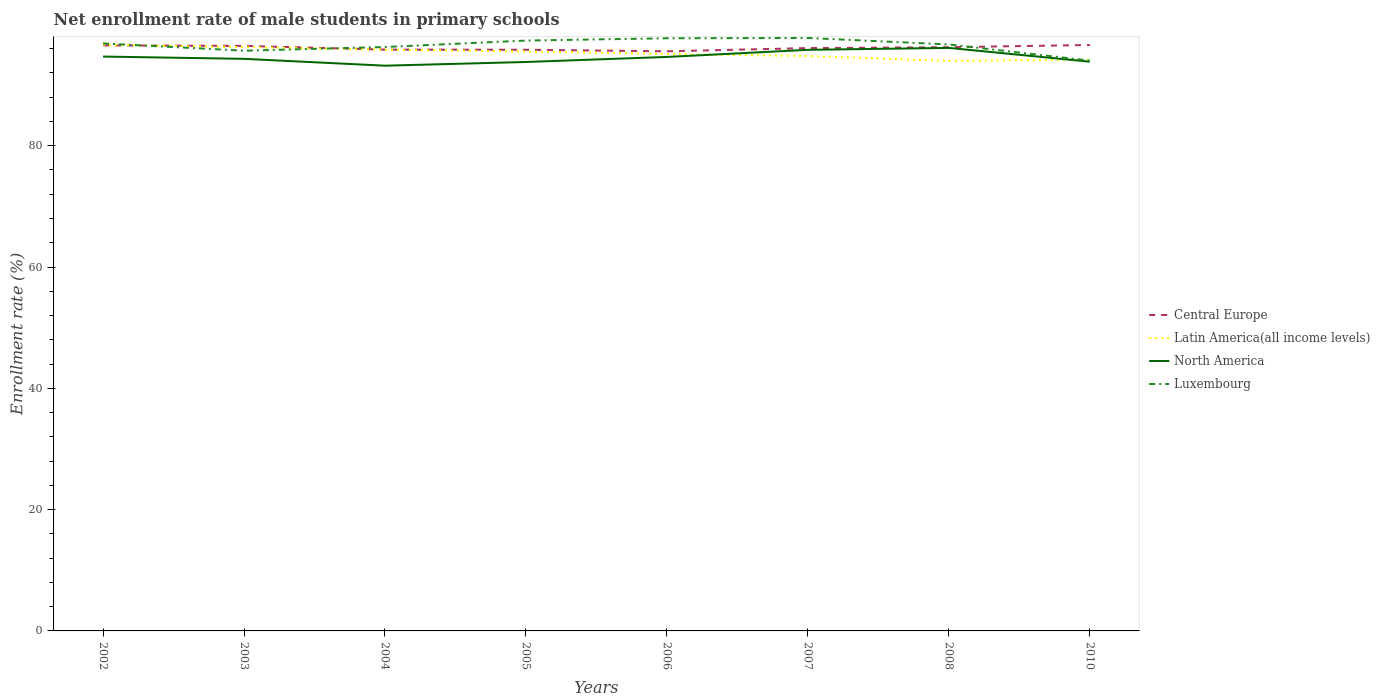Does the line corresponding to North America intersect with the line corresponding to Central Europe?
Your answer should be very brief. No. Across all years, what is the maximum net enrollment rate of male students in primary schools in Latin America(all income levels)?
Make the answer very short. 93.98. What is the total net enrollment rate of male students in primary schools in Central Europe in the graph?
Offer a terse response. 0.36. What is the difference between the highest and the second highest net enrollment rate of male students in primary schools in Luxembourg?
Ensure brevity in your answer.  3.74. Is the net enrollment rate of male students in primary schools in Latin America(all income levels) strictly greater than the net enrollment rate of male students in primary schools in Luxembourg over the years?
Keep it short and to the point. No. How many years are there in the graph?
Offer a very short reply. 8. Are the values on the major ticks of Y-axis written in scientific E-notation?
Offer a very short reply. No. Does the graph contain any zero values?
Your answer should be compact. No. Where does the legend appear in the graph?
Offer a terse response. Center right. How are the legend labels stacked?
Provide a short and direct response. Vertical. What is the title of the graph?
Make the answer very short. Net enrollment rate of male students in primary schools. What is the label or title of the Y-axis?
Offer a terse response. Enrollment rate (%). What is the Enrollment rate (%) of Central Europe in 2002?
Offer a very short reply. 96.54. What is the Enrollment rate (%) of Latin America(all income levels) in 2002?
Offer a terse response. 96.65. What is the Enrollment rate (%) in North America in 2002?
Offer a terse response. 94.7. What is the Enrollment rate (%) of Luxembourg in 2002?
Offer a terse response. 96.87. What is the Enrollment rate (%) in Central Europe in 2003?
Your answer should be very brief. 96.46. What is the Enrollment rate (%) in Latin America(all income levels) in 2003?
Your answer should be compact. 96.26. What is the Enrollment rate (%) of North America in 2003?
Keep it short and to the point. 94.32. What is the Enrollment rate (%) of Luxembourg in 2003?
Keep it short and to the point. 95.67. What is the Enrollment rate (%) of Central Europe in 2004?
Give a very brief answer. 95.85. What is the Enrollment rate (%) in Latin America(all income levels) in 2004?
Provide a succinct answer. 95.84. What is the Enrollment rate (%) in North America in 2004?
Your response must be concise. 93.19. What is the Enrollment rate (%) of Luxembourg in 2004?
Ensure brevity in your answer.  96.28. What is the Enrollment rate (%) in Central Europe in 2005?
Offer a terse response. 95.82. What is the Enrollment rate (%) of Latin America(all income levels) in 2005?
Offer a terse response. 95.53. What is the Enrollment rate (%) in North America in 2005?
Keep it short and to the point. 93.8. What is the Enrollment rate (%) in Luxembourg in 2005?
Make the answer very short. 97.34. What is the Enrollment rate (%) of Central Europe in 2006?
Your answer should be compact. 95.56. What is the Enrollment rate (%) in Latin America(all income levels) in 2006?
Provide a succinct answer. 95.13. What is the Enrollment rate (%) of North America in 2006?
Provide a succinct answer. 94.64. What is the Enrollment rate (%) in Luxembourg in 2006?
Your response must be concise. 97.72. What is the Enrollment rate (%) of Central Europe in 2007?
Your response must be concise. 96.1. What is the Enrollment rate (%) in Latin America(all income levels) in 2007?
Provide a succinct answer. 94.79. What is the Enrollment rate (%) in North America in 2007?
Provide a succinct answer. 95.81. What is the Enrollment rate (%) in Luxembourg in 2007?
Make the answer very short. 97.77. What is the Enrollment rate (%) of Central Europe in 2008?
Ensure brevity in your answer.  96.24. What is the Enrollment rate (%) of Latin America(all income levels) in 2008?
Offer a very short reply. 93.98. What is the Enrollment rate (%) in North America in 2008?
Offer a very short reply. 96.13. What is the Enrollment rate (%) in Luxembourg in 2008?
Provide a short and direct response. 96.69. What is the Enrollment rate (%) of Central Europe in 2010?
Provide a succinct answer. 96.6. What is the Enrollment rate (%) in Latin America(all income levels) in 2010?
Give a very brief answer. 94.16. What is the Enrollment rate (%) of North America in 2010?
Your answer should be compact. 93.85. What is the Enrollment rate (%) in Luxembourg in 2010?
Your answer should be very brief. 94.03. Across all years, what is the maximum Enrollment rate (%) in Central Europe?
Give a very brief answer. 96.6. Across all years, what is the maximum Enrollment rate (%) in Latin America(all income levels)?
Give a very brief answer. 96.65. Across all years, what is the maximum Enrollment rate (%) in North America?
Ensure brevity in your answer.  96.13. Across all years, what is the maximum Enrollment rate (%) of Luxembourg?
Keep it short and to the point. 97.77. Across all years, what is the minimum Enrollment rate (%) in Central Europe?
Your response must be concise. 95.56. Across all years, what is the minimum Enrollment rate (%) in Latin America(all income levels)?
Provide a succinct answer. 93.98. Across all years, what is the minimum Enrollment rate (%) of North America?
Your answer should be compact. 93.19. Across all years, what is the minimum Enrollment rate (%) in Luxembourg?
Make the answer very short. 94.03. What is the total Enrollment rate (%) in Central Europe in the graph?
Keep it short and to the point. 769.17. What is the total Enrollment rate (%) of Latin America(all income levels) in the graph?
Your answer should be very brief. 762.34. What is the total Enrollment rate (%) of North America in the graph?
Ensure brevity in your answer.  756.45. What is the total Enrollment rate (%) in Luxembourg in the graph?
Provide a succinct answer. 772.35. What is the difference between the Enrollment rate (%) of Central Europe in 2002 and that in 2003?
Provide a succinct answer. 0.09. What is the difference between the Enrollment rate (%) in Latin America(all income levels) in 2002 and that in 2003?
Your answer should be compact. 0.39. What is the difference between the Enrollment rate (%) in North America in 2002 and that in 2003?
Provide a succinct answer. 0.38. What is the difference between the Enrollment rate (%) of Luxembourg in 2002 and that in 2003?
Your answer should be very brief. 1.2. What is the difference between the Enrollment rate (%) in Central Europe in 2002 and that in 2004?
Provide a short and direct response. 0.7. What is the difference between the Enrollment rate (%) in Latin America(all income levels) in 2002 and that in 2004?
Provide a succinct answer. 0.82. What is the difference between the Enrollment rate (%) in North America in 2002 and that in 2004?
Your response must be concise. 1.5. What is the difference between the Enrollment rate (%) of Luxembourg in 2002 and that in 2004?
Make the answer very short. 0.59. What is the difference between the Enrollment rate (%) of Central Europe in 2002 and that in 2005?
Keep it short and to the point. 0.72. What is the difference between the Enrollment rate (%) in Latin America(all income levels) in 2002 and that in 2005?
Ensure brevity in your answer.  1.12. What is the difference between the Enrollment rate (%) in North America in 2002 and that in 2005?
Give a very brief answer. 0.89. What is the difference between the Enrollment rate (%) of Luxembourg in 2002 and that in 2005?
Offer a very short reply. -0.47. What is the difference between the Enrollment rate (%) in Central Europe in 2002 and that in 2006?
Offer a very short reply. 0.98. What is the difference between the Enrollment rate (%) in Latin America(all income levels) in 2002 and that in 2006?
Keep it short and to the point. 1.53. What is the difference between the Enrollment rate (%) of North America in 2002 and that in 2006?
Give a very brief answer. 0.06. What is the difference between the Enrollment rate (%) in Luxembourg in 2002 and that in 2006?
Your response must be concise. -0.85. What is the difference between the Enrollment rate (%) of Central Europe in 2002 and that in 2007?
Provide a succinct answer. 0.45. What is the difference between the Enrollment rate (%) in Latin America(all income levels) in 2002 and that in 2007?
Make the answer very short. 1.87. What is the difference between the Enrollment rate (%) of North America in 2002 and that in 2007?
Your answer should be very brief. -1.11. What is the difference between the Enrollment rate (%) in Luxembourg in 2002 and that in 2007?
Offer a very short reply. -0.9. What is the difference between the Enrollment rate (%) of Central Europe in 2002 and that in 2008?
Make the answer very short. 0.3. What is the difference between the Enrollment rate (%) of Latin America(all income levels) in 2002 and that in 2008?
Make the answer very short. 2.67. What is the difference between the Enrollment rate (%) of North America in 2002 and that in 2008?
Your response must be concise. -1.43. What is the difference between the Enrollment rate (%) in Luxembourg in 2002 and that in 2008?
Give a very brief answer. 0.17. What is the difference between the Enrollment rate (%) of Central Europe in 2002 and that in 2010?
Your answer should be compact. -0.06. What is the difference between the Enrollment rate (%) of Latin America(all income levels) in 2002 and that in 2010?
Your response must be concise. 2.49. What is the difference between the Enrollment rate (%) in North America in 2002 and that in 2010?
Ensure brevity in your answer.  0.85. What is the difference between the Enrollment rate (%) in Luxembourg in 2002 and that in 2010?
Your response must be concise. 2.84. What is the difference between the Enrollment rate (%) in Central Europe in 2003 and that in 2004?
Your answer should be very brief. 0.61. What is the difference between the Enrollment rate (%) of Latin America(all income levels) in 2003 and that in 2004?
Keep it short and to the point. 0.42. What is the difference between the Enrollment rate (%) of North America in 2003 and that in 2004?
Your response must be concise. 1.13. What is the difference between the Enrollment rate (%) in Luxembourg in 2003 and that in 2004?
Offer a very short reply. -0.61. What is the difference between the Enrollment rate (%) in Central Europe in 2003 and that in 2005?
Ensure brevity in your answer.  0.63. What is the difference between the Enrollment rate (%) in Latin America(all income levels) in 2003 and that in 2005?
Provide a succinct answer. 0.73. What is the difference between the Enrollment rate (%) of North America in 2003 and that in 2005?
Offer a terse response. 0.52. What is the difference between the Enrollment rate (%) in Luxembourg in 2003 and that in 2005?
Ensure brevity in your answer.  -1.67. What is the difference between the Enrollment rate (%) in Central Europe in 2003 and that in 2006?
Your response must be concise. 0.89. What is the difference between the Enrollment rate (%) of Latin America(all income levels) in 2003 and that in 2006?
Ensure brevity in your answer.  1.13. What is the difference between the Enrollment rate (%) of North America in 2003 and that in 2006?
Give a very brief answer. -0.31. What is the difference between the Enrollment rate (%) in Luxembourg in 2003 and that in 2006?
Your answer should be very brief. -2.05. What is the difference between the Enrollment rate (%) of Central Europe in 2003 and that in 2007?
Provide a succinct answer. 0.36. What is the difference between the Enrollment rate (%) of Latin America(all income levels) in 2003 and that in 2007?
Offer a terse response. 1.47. What is the difference between the Enrollment rate (%) of North America in 2003 and that in 2007?
Offer a terse response. -1.49. What is the difference between the Enrollment rate (%) in Luxembourg in 2003 and that in 2007?
Give a very brief answer. -2.1. What is the difference between the Enrollment rate (%) in Central Europe in 2003 and that in 2008?
Provide a succinct answer. 0.21. What is the difference between the Enrollment rate (%) of Latin America(all income levels) in 2003 and that in 2008?
Provide a short and direct response. 2.28. What is the difference between the Enrollment rate (%) in North America in 2003 and that in 2008?
Make the answer very short. -1.8. What is the difference between the Enrollment rate (%) in Luxembourg in 2003 and that in 2008?
Give a very brief answer. -1.03. What is the difference between the Enrollment rate (%) in Central Europe in 2003 and that in 2010?
Offer a very short reply. -0.15. What is the difference between the Enrollment rate (%) in Latin America(all income levels) in 2003 and that in 2010?
Provide a succinct answer. 2.1. What is the difference between the Enrollment rate (%) of North America in 2003 and that in 2010?
Provide a short and direct response. 0.47. What is the difference between the Enrollment rate (%) in Luxembourg in 2003 and that in 2010?
Give a very brief answer. 1.64. What is the difference between the Enrollment rate (%) of Central Europe in 2004 and that in 2005?
Make the answer very short. 0.02. What is the difference between the Enrollment rate (%) of Latin America(all income levels) in 2004 and that in 2005?
Keep it short and to the point. 0.3. What is the difference between the Enrollment rate (%) in North America in 2004 and that in 2005?
Your answer should be very brief. -0.61. What is the difference between the Enrollment rate (%) in Luxembourg in 2004 and that in 2005?
Your answer should be compact. -1.06. What is the difference between the Enrollment rate (%) in Central Europe in 2004 and that in 2006?
Your response must be concise. 0.28. What is the difference between the Enrollment rate (%) of Latin America(all income levels) in 2004 and that in 2006?
Offer a very short reply. 0.71. What is the difference between the Enrollment rate (%) of North America in 2004 and that in 2006?
Your answer should be compact. -1.44. What is the difference between the Enrollment rate (%) of Luxembourg in 2004 and that in 2006?
Your answer should be very brief. -1.44. What is the difference between the Enrollment rate (%) of Central Europe in 2004 and that in 2007?
Offer a terse response. -0.25. What is the difference between the Enrollment rate (%) of Latin America(all income levels) in 2004 and that in 2007?
Your answer should be compact. 1.05. What is the difference between the Enrollment rate (%) of North America in 2004 and that in 2007?
Provide a short and direct response. -2.62. What is the difference between the Enrollment rate (%) of Luxembourg in 2004 and that in 2007?
Your response must be concise. -1.49. What is the difference between the Enrollment rate (%) of Central Europe in 2004 and that in 2008?
Ensure brevity in your answer.  -0.4. What is the difference between the Enrollment rate (%) of Latin America(all income levels) in 2004 and that in 2008?
Your answer should be very brief. 1.86. What is the difference between the Enrollment rate (%) in North America in 2004 and that in 2008?
Ensure brevity in your answer.  -2.93. What is the difference between the Enrollment rate (%) of Luxembourg in 2004 and that in 2008?
Your answer should be compact. -0.42. What is the difference between the Enrollment rate (%) of Central Europe in 2004 and that in 2010?
Ensure brevity in your answer.  -0.76. What is the difference between the Enrollment rate (%) of Latin America(all income levels) in 2004 and that in 2010?
Offer a terse response. 1.67. What is the difference between the Enrollment rate (%) of North America in 2004 and that in 2010?
Your answer should be very brief. -0.66. What is the difference between the Enrollment rate (%) in Luxembourg in 2004 and that in 2010?
Your answer should be compact. 2.25. What is the difference between the Enrollment rate (%) of Central Europe in 2005 and that in 2006?
Offer a very short reply. 0.26. What is the difference between the Enrollment rate (%) of Latin America(all income levels) in 2005 and that in 2006?
Offer a very short reply. 0.41. What is the difference between the Enrollment rate (%) in North America in 2005 and that in 2006?
Give a very brief answer. -0.83. What is the difference between the Enrollment rate (%) in Luxembourg in 2005 and that in 2006?
Provide a short and direct response. -0.38. What is the difference between the Enrollment rate (%) in Central Europe in 2005 and that in 2007?
Give a very brief answer. -0.28. What is the difference between the Enrollment rate (%) in Latin America(all income levels) in 2005 and that in 2007?
Offer a very short reply. 0.75. What is the difference between the Enrollment rate (%) of North America in 2005 and that in 2007?
Give a very brief answer. -2.01. What is the difference between the Enrollment rate (%) in Luxembourg in 2005 and that in 2007?
Your response must be concise. -0.43. What is the difference between the Enrollment rate (%) in Central Europe in 2005 and that in 2008?
Provide a succinct answer. -0.42. What is the difference between the Enrollment rate (%) of Latin America(all income levels) in 2005 and that in 2008?
Give a very brief answer. 1.55. What is the difference between the Enrollment rate (%) of North America in 2005 and that in 2008?
Give a very brief answer. -2.32. What is the difference between the Enrollment rate (%) of Luxembourg in 2005 and that in 2008?
Provide a short and direct response. 0.64. What is the difference between the Enrollment rate (%) in Central Europe in 2005 and that in 2010?
Your response must be concise. -0.78. What is the difference between the Enrollment rate (%) of Latin America(all income levels) in 2005 and that in 2010?
Keep it short and to the point. 1.37. What is the difference between the Enrollment rate (%) in North America in 2005 and that in 2010?
Keep it short and to the point. -0.05. What is the difference between the Enrollment rate (%) of Luxembourg in 2005 and that in 2010?
Keep it short and to the point. 3.31. What is the difference between the Enrollment rate (%) in Central Europe in 2006 and that in 2007?
Provide a short and direct response. -0.53. What is the difference between the Enrollment rate (%) in Latin America(all income levels) in 2006 and that in 2007?
Ensure brevity in your answer.  0.34. What is the difference between the Enrollment rate (%) of North America in 2006 and that in 2007?
Provide a short and direct response. -1.17. What is the difference between the Enrollment rate (%) in Luxembourg in 2006 and that in 2007?
Keep it short and to the point. -0.05. What is the difference between the Enrollment rate (%) in Central Europe in 2006 and that in 2008?
Make the answer very short. -0.68. What is the difference between the Enrollment rate (%) in Latin America(all income levels) in 2006 and that in 2008?
Your answer should be very brief. 1.15. What is the difference between the Enrollment rate (%) of North America in 2006 and that in 2008?
Offer a very short reply. -1.49. What is the difference between the Enrollment rate (%) in Luxembourg in 2006 and that in 2008?
Provide a succinct answer. 1.02. What is the difference between the Enrollment rate (%) of Central Europe in 2006 and that in 2010?
Keep it short and to the point. -1.04. What is the difference between the Enrollment rate (%) of Latin America(all income levels) in 2006 and that in 2010?
Your response must be concise. 0.96. What is the difference between the Enrollment rate (%) in North America in 2006 and that in 2010?
Offer a terse response. 0.79. What is the difference between the Enrollment rate (%) of Luxembourg in 2006 and that in 2010?
Your answer should be very brief. 3.69. What is the difference between the Enrollment rate (%) in Central Europe in 2007 and that in 2008?
Provide a succinct answer. -0.14. What is the difference between the Enrollment rate (%) of Latin America(all income levels) in 2007 and that in 2008?
Your answer should be very brief. 0.81. What is the difference between the Enrollment rate (%) of North America in 2007 and that in 2008?
Keep it short and to the point. -0.32. What is the difference between the Enrollment rate (%) in Luxembourg in 2007 and that in 2008?
Offer a very short reply. 1.07. What is the difference between the Enrollment rate (%) in Central Europe in 2007 and that in 2010?
Keep it short and to the point. -0.51. What is the difference between the Enrollment rate (%) of Latin America(all income levels) in 2007 and that in 2010?
Make the answer very short. 0.63. What is the difference between the Enrollment rate (%) in North America in 2007 and that in 2010?
Offer a terse response. 1.96. What is the difference between the Enrollment rate (%) in Luxembourg in 2007 and that in 2010?
Ensure brevity in your answer.  3.74. What is the difference between the Enrollment rate (%) of Central Europe in 2008 and that in 2010?
Offer a terse response. -0.36. What is the difference between the Enrollment rate (%) in Latin America(all income levels) in 2008 and that in 2010?
Make the answer very short. -0.18. What is the difference between the Enrollment rate (%) of North America in 2008 and that in 2010?
Offer a terse response. 2.28. What is the difference between the Enrollment rate (%) in Luxembourg in 2008 and that in 2010?
Ensure brevity in your answer.  2.66. What is the difference between the Enrollment rate (%) in Central Europe in 2002 and the Enrollment rate (%) in Latin America(all income levels) in 2003?
Ensure brevity in your answer.  0.28. What is the difference between the Enrollment rate (%) in Central Europe in 2002 and the Enrollment rate (%) in North America in 2003?
Offer a very short reply. 2.22. What is the difference between the Enrollment rate (%) in Central Europe in 2002 and the Enrollment rate (%) in Luxembourg in 2003?
Give a very brief answer. 0.88. What is the difference between the Enrollment rate (%) of Latin America(all income levels) in 2002 and the Enrollment rate (%) of North America in 2003?
Offer a very short reply. 2.33. What is the difference between the Enrollment rate (%) of North America in 2002 and the Enrollment rate (%) of Luxembourg in 2003?
Make the answer very short. -0.97. What is the difference between the Enrollment rate (%) of Central Europe in 2002 and the Enrollment rate (%) of Latin America(all income levels) in 2004?
Ensure brevity in your answer.  0.71. What is the difference between the Enrollment rate (%) in Central Europe in 2002 and the Enrollment rate (%) in North America in 2004?
Your answer should be compact. 3.35. What is the difference between the Enrollment rate (%) of Central Europe in 2002 and the Enrollment rate (%) of Luxembourg in 2004?
Offer a terse response. 0.27. What is the difference between the Enrollment rate (%) in Latin America(all income levels) in 2002 and the Enrollment rate (%) in North America in 2004?
Provide a succinct answer. 3.46. What is the difference between the Enrollment rate (%) in Latin America(all income levels) in 2002 and the Enrollment rate (%) in Luxembourg in 2004?
Ensure brevity in your answer.  0.38. What is the difference between the Enrollment rate (%) in North America in 2002 and the Enrollment rate (%) in Luxembourg in 2004?
Make the answer very short. -1.58. What is the difference between the Enrollment rate (%) of Central Europe in 2002 and the Enrollment rate (%) of Latin America(all income levels) in 2005?
Your response must be concise. 1.01. What is the difference between the Enrollment rate (%) in Central Europe in 2002 and the Enrollment rate (%) in North America in 2005?
Make the answer very short. 2.74. What is the difference between the Enrollment rate (%) of Central Europe in 2002 and the Enrollment rate (%) of Luxembourg in 2005?
Offer a terse response. -0.79. What is the difference between the Enrollment rate (%) of Latin America(all income levels) in 2002 and the Enrollment rate (%) of North America in 2005?
Offer a terse response. 2.85. What is the difference between the Enrollment rate (%) of Latin America(all income levels) in 2002 and the Enrollment rate (%) of Luxembourg in 2005?
Make the answer very short. -0.68. What is the difference between the Enrollment rate (%) of North America in 2002 and the Enrollment rate (%) of Luxembourg in 2005?
Your answer should be very brief. -2.64. What is the difference between the Enrollment rate (%) in Central Europe in 2002 and the Enrollment rate (%) in Latin America(all income levels) in 2006?
Your answer should be compact. 1.42. What is the difference between the Enrollment rate (%) in Central Europe in 2002 and the Enrollment rate (%) in North America in 2006?
Make the answer very short. 1.91. What is the difference between the Enrollment rate (%) in Central Europe in 2002 and the Enrollment rate (%) in Luxembourg in 2006?
Provide a succinct answer. -1.17. What is the difference between the Enrollment rate (%) in Latin America(all income levels) in 2002 and the Enrollment rate (%) in North America in 2006?
Offer a very short reply. 2.02. What is the difference between the Enrollment rate (%) of Latin America(all income levels) in 2002 and the Enrollment rate (%) of Luxembourg in 2006?
Your answer should be very brief. -1.06. What is the difference between the Enrollment rate (%) of North America in 2002 and the Enrollment rate (%) of Luxembourg in 2006?
Offer a terse response. -3.02. What is the difference between the Enrollment rate (%) in Central Europe in 2002 and the Enrollment rate (%) in Latin America(all income levels) in 2007?
Offer a terse response. 1.75. What is the difference between the Enrollment rate (%) in Central Europe in 2002 and the Enrollment rate (%) in North America in 2007?
Give a very brief answer. 0.73. What is the difference between the Enrollment rate (%) in Central Europe in 2002 and the Enrollment rate (%) in Luxembourg in 2007?
Ensure brevity in your answer.  -1.22. What is the difference between the Enrollment rate (%) in Latin America(all income levels) in 2002 and the Enrollment rate (%) in North America in 2007?
Your response must be concise. 0.84. What is the difference between the Enrollment rate (%) in Latin America(all income levels) in 2002 and the Enrollment rate (%) in Luxembourg in 2007?
Offer a very short reply. -1.11. What is the difference between the Enrollment rate (%) in North America in 2002 and the Enrollment rate (%) in Luxembourg in 2007?
Your answer should be compact. -3.07. What is the difference between the Enrollment rate (%) of Central Europe in 2002 and the Enrollment rate (%) of Latin America(all income levels) in 2008?
Provide a succinct answer. 2.56. What is the difference between the Enrollment rate (%) of Central Europe in 2002 and the Enrollment rate (%) of North America in 2008?
Provide a succinct answer. 0.41. What is the difference between the Enrollment rate (%) of Central Europe in 2002 and the Enrollment rate (%) of Luxembourg in 2008?
Keep it short and to the point. -0.15. What is the difference between the Enrollment rate (%) in Latin America(all income levels) in 2002 and the Enrollment rate (%) in North America in 2008?
Provide a short and direct response. 0.53. What is the difference between the Enrollment rate (%) of Latin America(all income levels) in 2002 and the Enrollment rate (%) of Luxembourg in 2008?
Offer a terse response. -0.04. What is the difference between the Enrollment rate (%) in North America in 2002 and the Enrollment rate (%) in Luxembourg in 2008?
Offer a terse response. -2. What is the difference between the Enrollment rate (%) of Central Europe in 2002 and the Enrollment rate (%) of Latin America(all income levels) in 2010?
Provide a short and direct response. 2.38. What is the difference between the Enrollment rate (%) in Central Europe in 2002 and the Enrollment rate (%) in North America in 2010?
Make the answer very short. 2.69. What is the difference between the Enrollment rate (%) in Central Europe in 2002 and the Enrollment rate (%) in Luxembourg in 2010?
Keep it short and to the point. 2.51. What is the difference between the Enrollment rate (%) of Latin America(all income levels) in 2002 and the Enrollment rate (%) of North America in 2010?
Give a very brief answer. 2.8. What is the difference between the Enrollment rate (%) in Latin America(all income levels) in 2002 and the Enrollment rate (%) in Luxembourg in 2010?
Make the answer very short. 2.62. What is the difference between the Enrollment rate (%) in North America in 2002 and the Enrollment rate (%) in Luxembourg in 2010?
Give a very brief answer. 0.67. What is the difference between the Enrollment rate (%) in Central Europe in 2003 and the Enrollment rate (%) in Latin America(all income levels) in 2004?
Your answer should be very brief. 0.62. What is the difference between the Enrollment rate (%) in Central Europe in 2003 and the Enrollment rate (%) in North America in 2004?
Ensure brevity in your answer.  3.26. What is the difference between the Enrollment rate (%) in Central Europe in 2003 and the Enrollment rate (%) in Luxembourg in 2004?
Offer a terse response. 0.18. What is the difference between the Enrollment rate (%) of Latin America(all income levels) in 2003 and the Enrollment rate (%) of North America in 2004?
Ensure brevity in your answer.  3.06. What is the difference between the Enrollment rate (%) in Latin America(all income levels) in 2003 and the Enrollment rate (%) in Luxembourg in 2004?
Offer a very short reply. -0.02. What is the difference between the Enrollment rate (%) in North America in 2003 and the Enrollment rate (%) in Luxembourg in 2004?
Offer a terse response. -1.95. What is the difference between the Enrollment rate (%) of Central Europe in 2003 and the Enrollment rate (%) of Latin America(all income levels) in 2005?
Your answer should be very brief. 0.92. What is the difference between the Enrollment rate (%) in Central Europe in 2003 and the Enrollment rate (%) in North America in 2005?
Your response must be concise. 2.65. What is the difference between the Enrollment rate (%) of Central Europe in 2003 and the Enrollment rate (%) of Luxembourg in 2005?
Offer a very short reply. -0.88. What is the difference between the Enrollment rate (%) of Latin America(all income levels) in 2003 and the Enrollment rate (%) of North America in 2005?
Your response must be concise. 2.45. What is the difference between the Enrollment rate (%) of Latin America(all income levels) in 2003 and the Enrollment rate (%) of Luxembourg in 2005?
Ensure brevity in your answer.  -1.08. What is the difference between the Enrollment rate (%) in North America in 2003 and the Enrollment rate (%) in Luxembourg in 2005?
Offer a terse response. -3.01. What is the difference between the Enrollment rate (%) of Central Europe in 2003 and the Enrollment rate (%) of Latin America(all income levels) in 2006?
Ensure brevity in your answer.  1.33. What is the difference between the Enrollment rate (%) of Central Europe in 2003 and the Enrollment rate (%) of North America in 2006?
Your answer should be compact. 1.82. What is the difference between the Enrollment rate (%) in Central Europe in 2003 and the Enrollment rate (%) in Luxembourg in 2006?
Offer a terse response. -1.26. What is the difference between the Enrollment rate (%) in Latin America(all income levels) in 2003 and the Enrollment rate (%) in North America in 2006?
Offer a terse response. 1.62. What is the difference between the Enrollment rate (%) in Latin America(all income levels) in 2003 and the Enrollment rate (%) in Luxembourg in 2006?
Provide a short and direct response. -1.46. What is the difference between the Enrollment rate (%) of North America in 2003 and the Enrollment rate (%) of Luxembourg in 2006?
Your answer should be compact. -3.39. What is the difference between the Enrollment rate (%) of Central Europe in 2003 and the Enrollment rate (%) of Latin America(all income levels) in 2007?
Offer a terse response. 1.67. What is the difference between the Enrollment rate (%) of Central Europe in 2003 and the Enrollment rate (%) of North America in 2007?
Give a very brief answer. 0.65. What is the difference between the Enrollment rate (%) of Central Europe in 2003 and the Enrollment rate (%) of Luxembourg in 2007?
Keep it short and to the point. -1.31. What is the difference between the Enrollment rate (%) in Latin America(all income levels) in 2003 and the Enrollment rate (%) in North America in 2007?
Make the answer very short. 0.45. What is the difference between the Enrollment rate (%) of Latin America(all income levels) in 2003 and the Enrollment rate (%) of Luxembourg in 2007?
Your answer should be very brief. -1.51. What is the difference between the Enrollment rate (%) in North America in 2003 and the Enrollment rate (%) in Luxembourg in 2007?
Keep it short and to the point. -3.44. What is the difference between the Enrollment rate (%) in Central Europe in 2003 and the Enrollment rate (%) in Latin America(all income levels) in 2008?
Make the answer very short. 2.48. What is the difference between the Enrollment rate (%) of Central Europe in 2003 and the Enrollment rate (%) of North America in 2008?
Keep it short and to the point. 0.33. What is the difference between the Enrollment rate (%) in Central Europe in 2003 and the Enrollment rate (%) in Luxembourg in 2008?
Your response must be concise. -0.24. What is the difference between the Enrollment rate (%) in Latin America(all income levels) in 2003 and the Enrollment rate (%) in North America in 2008?
Provide a short and direct response. 0.13. What is the difference between the Enrollment rate (%) of Latin America(all income levels) in 2003 and the Enrollment rate (%) of Luxembourg in 2008?
Provide a short and direct response. -0.43. What is the difference between the Enrollment rate (%) in North America in 2003 and the Enrollment rate (%) in Luxembourg in 2008?
Keep it short and to the point. -2.37. What is the difference between the Enrollment rate (%) of Central Europe in 2003 and the Enrollment rate (%) of Latin America(all income levels) in 2010?
Offer a very short reply. 2.29. What is the difference between the Enrollment rate (%) of Central Europe in 2003 and the Enrollment rate (%) of North America in 2010?
Ensure brevity in your answer.  2.6. What is the difference between the Enrollment rate (%) in Central Europe in 2003 and the Enrollment rate (%) in Luxembourg in 2010?
Make the answer very short. 2.43. What is the difference between the Enrollment rate (%) in Latin America(all income levels) in 2003 and the Enrollment rate (%) in North America in 2010?
Your answer should be very brief. 2.41. What is the difference between the Enrollment rate (%) in Latin America(all income levels) in 2003 and the Enrollment rate (%) in Luxembourg in 2010?
Provide a short and direct response. 2.23. What is the difference between the Enrollment rate (%) of North America in 2003 and the Enrollment rate (%) of Luxembourg in 2010?
Provide a succinct answer. 0.29. What is the difference between the Enrollment rate (%) in Central Europe in 2004 and the Enrollment rate (%) in Latin America(all income levels) in 2005?
Provide a short and direct response. 0.31. What is the difference between the Enrollment rate (%) of Central Europe in 2004 and the Enrollment rate (%) of North America in 2005?
Provide a short and direct response. 2.04. What is the difference between the Enrollment rate (%) of Central Europe in 2004 and the Enrollment rate (%) of Luxembourg in 2005?
Your answer should be very brief. -1.49. What is the difference between the Enrollment rate (%) of Latin America(all income levels) in 2004 and the Enrollment rate (%) of North America in 2005?
Your response must be concise. 2.03. What is the difference between the Enrollment rate (%) in Latin America(all income levels) in 2004 and the Enrollment rate (%) in Luxembourg in 2005?
Give a very brief answer. -1.5. What is the difference between the Enrollment rate (%) of North America in 2004 and the Enrollment rate (%) of Luxembourg in 2005?
Your response must be concise. -4.14. What is the difference between the Enrollment rate (%) of Central Europe in 2004 and the Enrollment rate (%) of Latin America(all income levels) in 2006?
Offer a terse response. 0.72. What is the difference between the Enrollment rate (%) in Central Europe in 2004 and the Enrollment rate (%) in North America in 2006?
Your response must be concise. 1.21. What is the difference between the Enrollment rate (%) in Central Europe in 2004 and the Enrollment rate (%) in Luxembourg in 2006?
Your response must be concise. -1.87. What is the difference between the Enrollment rate (%) of Latin America(all income levels) in 2004 and the Enrollment rate (%) of Luxembourg in 2006?
Offer a terse response. -1.88. What is the difference between the Enrollment rate (%) of North America in 2004 and the Enrollment rate (%) of Luxembourg in 2006?
Keep it short and to the point. -4.52. What is the difference between the Enrollment rate (%) of Central Europe in 2004 and the Enrollment rate (%) of Latin America(all income levels) in 2007?
Your answer should be very brief. 1.06. What is the difference between the Enrollment rate (%) of Central Europe in 2004 and the Enrollment rate (%) of North America in 2007?
Provide a succinct answer. 0.04. What is the difference between the Enrollment rate (%) of Central Europe in 2004 and the Enrollment rate (%) of Luxembourg in 2007?
Your answer should be very brief. -1.92. What is the difference between the Enrollment rate (%) in Latin America(all income levels) in 2004 and the Enrollment rate (%) in North America in 2007?
Provide a succinct answer. 0.03. What is the difference between the Enrollment rate (%) of Latin America(all income levels) in 2004 and the Enrollment rate (%) of Luxembourg in 2007?
Your answer should be very brief. -1.93. What is the difference between the Enrollment rate (%) of North America in 2004 and the Enrollment rate (%) of Luxembourg in 2007?
Provide a short and direct response. -4.57. What is the difference between the Enrollment rate (%) in Central Europe in 2004 and the Enrollment rate (%) in Latin America(all income levels) in 2008?
Offer a terse response. 1.87. What is the difference between the Enrollment rate (%) of Central Europe in 2004 and the Enrollment rate (%) of North America in 2008?
Keep it short and to the point. -0.28. What is the difference between the Enrollment rate (%) in Central Europe in 2004 and the Enrollment rate (%) in Luxembourg in 2008?
Give a very brief answer. -0.85. What is the difference between the Enrollment rate (%) of Latin America(all income levels) in 2004 and the Enrollment rate (%) of North America in 2008?
Your response must be concise. -0.29. What is the difference between the Enrollment rate (%) of Latin America(all income levels) in 2004 and the Enrollment rate (%) of Luxembourg in 2008?
Offer a very short reply. -0.86. What is the difference between the Enrollment rate (%) in North America in 2004 and the Enrollment rate (%) in Luxembourg in 2008?
Provide a succinct answer. -3.5. What is the difference between the Enrollment rate (%) of Central Europe in 2004 and the Enrollment rate (%) of Latin America(all income levels) in 2010?
Offer a very short reply. 1.68. What is the difference between the Enrollment rate (%) of Central Europe in 2004 and the Enrollment rate (%) of North America in 2010?
Keep it short and to the point. 1.99. What is the difference between the Enrollment rate (%) of Central Europe in 2004 and the Enrollment rate (%) of Luxembourg in 2010?
Offer a terse response. 1.82. What is the difference between the Enrollment rate (%) of Latin America(all income levels) in 2004 and the Enrollment rate (%) of North America in 2010?
Provide a succinct answer. 1.99. What is the difference between the Enrollment rate (%) of Latin America(all income levels) in 2004 and the Enrollment rate (%) of Luxembourg in 2010?
Your answer should be compact. 1.81. What is the difference between the Enrollment rate (%) in North America in 2004 and the Enrollment rate (%) in Luxembourg in 2010?
Offer a very short reply. -0.84. What is the difference between the Enrollment rate (%) of Central Europe in 2005 and the Enrollment rate (%) of Latin America(all income levels) in 2006?
Your response must be concise. 0.7. What is the difference between the Enrollment rate (%) in Central Europe in 2005 and the Enrollment rate (%) in North America in 2006?
Your response must be concise. 1.18. What is the difference between the Enrollment rate (%) of Central Europe in 2005 and the Enrollment rate (%) of Luxembourg in 2006?
Make the answer very short. -1.89. What is the difference between the Enrollment rate (%) in Latin America(all income levels) in 2005 and the Enrollment rate (%) in North America in 2006?
Give a very brief answer. 0.9. What is the difference between the Enrollment rate (%) in Latin America(all income levels) in 2005 and the Enrollment rate (%) in Luxembourg in 2006?
Your response must be concise. -2.18. What is the difference between the Enrollment rate (%) of North America in 2005 and the Enrollment rate (%) of Luxembourg in 2006?
Your response must be concise. -3.91. What is the difference between the Enrollment rate (%) of Central Europe in 2005 and the Enrollment rate (%) of Latin America(all income levels) in 2007?
Make the answer very short. 1.03. What is the difference between the Enrollment rate (%) in Central Europe in 2005 and the Enrollment rate (%) in North America in 2007?
Offer a terse response. 0.01. What is the difference between the Enrollment rate (%) of Central Europe in 2005 and the Enrollment rate (%) of Luxembourg in 2007?
Provide a short and direct response. -1.94. What is the difference between the Enrollment rate (%) of Latin America(all income levels) in 2005 and the Enrollment rate (%) of North America in 2007?
Make the answer very short. -0.28. What is the difference between the Enrollment rate (%) in Latin America(all income levels) in 2005 and the Enrollment rate (%) in Luxembourg in 2007?
Your answer should be very brief. -2.23. What is the difference between the Enrollment rate (%) in North America in 2005 and the Enrollment rate (%) in Luxembourg in 2007?
Provide a short and direct response. -3.96. What is the difference between the Enrollment rate (%) of Central Europe in 2005 and the Enrollment rate (%) of Latin America(all income levels) in 2008?
Your response must be concise. 1.84. What is the difference between the Enrollment rate (%) of Central Europe in 2005 and the Enrollment rate (%) of North America in 2008?
Offer a very short reply. -0.31. What is the difference between the Enrollment rate (%) of Central Europe in 2005 and the Enrollment rate (%) of Luxembourg in 2008?
Give a very brief answer. -0.87. What is the difference between the Enrollment rate (%) of Latin America(all income levels) in 2005 and the Enrollment rate (%) of North America in 2008?
Offer a terse response. -0.59. What is the difference between the Enrollment rate (%) in Latin America(all income levels) in 2005 and the Enrollment rate (%) in Luxembourg in 2008?
Your answer should be compact. -1.16. What is the difference between the Enrollment rate (%) of North America in 2005 and the Enrollment rate (%) of Luxembourg in 2008?
Ensure brevity in your answer.  -2.89. What is the difference between the Enrollment rate (%) in Central Europe in 2005 and the Enrollment rate (%) in Latin America(all income levels) in 2010?
Offer a terse response. 1.66. What is the difference between the Enrollment rate (%) of Central Europe in 2005 and the Enrollment rate (%) of North America in 2010?
Your answer should be very brief. 1.97. What is the difference between the Enrollment rate (%) of Central Europe in 2005 and the Enrollment rate (%) of Luxembourg in 2010?
Make the answer very short. 1.79. What is the difference between the Enrollment rate (%) of Latin America(all income levels) in 2005 and the Enrollment rate (%) of North America in 2010?
Your answer should be very brief. 1.68. What is the difference between the Enrollment rate (%) in Latin America(all income levels) in 2005 and the Enrollment rate (%) in Luxembourg in 2010?
Your answer should be very brief. 1.5. What is the difference between the Enrollment rate (%) of North America in 2005 and the Enrollment rate (%) of Luxembourg in 2010?
Provide a short and direct response. -0.23. What is the difference between the Enrollment rate (%) in Central Europe in 2006 and the Enrollment rate (%) in Latin America(all income levels) in 2007?
Make the answer very short. 0.78. What is the difference between the Enrollment rate (%) of Central Europe in 2006 and the Enrollment rate (%) of North America in 2007?
Your response must be concise. -0.25. What is the difference between the Enrollment rate (%) in Central Europe in 2006 and the Enrollment rate (%) in Luxembourg in 2007?
Provide a succinct answer. -2.2. What is the difference between the Enrollment rate (%) of Latin America(all income levels) in 2006 and the Enrollment rate (%) of North America in 2007?
Give a very brief answer. -0.68. What is the difference between the Enrollment rate (%) in Latin America(all income levels) in 2006 and the Enrollment rate (%) in Luxembourg in 2007?
Your answer should be very brief. -2.64. What is the difference between the Enrollment rate (%) in North America in 2006 and the Enrollment rate (%) in Luxembourg in 2007?
Make the answer very short. -3.13. What is the difference between the Enrollment rate (%) in Central Europe in 2006 and the Enrollment rate (%) in Latin America(all income levels) in 2008?
Ensure brevity in your answer.  1.59. What is the difference between the Enrollment rate (%) in Central Europe in 2006 and the Enrollment rate (%) in North America in 2008?
Give a very brief answer. -0.56. What is the difference between the Enrollment rate (%) in Central Europe in 2006 and the Enrollment rate (%) in Luxembourg in 2008?
Give a very brief answer. -1.13. What is the difference between the Enrollment rate (%) of Latin America(all income levels) in 2006 and the Enrollment rate (%) of North America in 2008?
Your response must be concise. -1. What is the difference between the Enrollment rate (%) in Latin America(all income levels) in 2006 and the Enrollment rate (%) in Luxembourg in 2008?
Your response must be concise. -1.57. What is the difference between the Enrollment rate (%) of North America in 2006 and the Enrollment rate (%) of Luxembourg in 2008?
Offer a very short reply. -2.06. What is the difference between the Enrollment rate (%) in Central Europe in 2006 and the Enrollment rate (%) in Latin America(all income levels) in 2010?
Your answer should be very brief. 1.4. What is the difference between the Enrollment rate (%) in Central Europe in 2006 and the Enrollment rate (%) in North America in 2010?
Ensure brevity in your answer.  1.71. What is the difference between the Enrollment rate (%) of Central Europe in 2006 and the Enrollment rate (%) of Luxembourg in 2010?
Provide a short and direct response. 1.53. What is the difference between the Enrollment rate (%) of Latin America(all income levels) in 2006 and the Enrollment rate (%) of North America in 2010?
Offer a very short reply. 1.27. What is the difference between the Enrollment rate (%) of Latin America(all income levels) in 2006 and the Enrollment rate (%) of Luxembourg in 2010?
Your response must be concise. 1.1. What is the difference between the Enrollment rate (%) in North America in 2006 and the Enrollment rate (%) in Luxembourg in 2010?
Offer a very short reply. 0.61. What is the difference between the Enrollment rate (%) in Central Europe in 2007 and the Enrollment rate (%) in Latin America(all income levels) in 2008?
Keep it short and to the point. 2.12. What is the difference between the Enrollment rate (%) in Central Europe in 2007 and the Enrollment rate (%) in North America in 2008?
Keep it short and to the point. -0.03. What is the difference between the Enrollment rate (%) of Central Europe in 2007 and the Enrollment rate (%) of Luxembourg in 2008?
Give a very brief answer. -0.6. What is the difference between the Enrollment rate (%) of Latin America(all income levels) in 2007 and the Enrollment rate (%) of North America in 2008?
Your response must be concise. -1.34. What is the difference between the Enrollment rate (%) of Latin America(all income levels) in 2007 and the Enrollment rate (%) of Luxembourg in 2008?
Ensure brevity in your answer.  -1.91. What is the difference between the Enrollment rate (%) of North America in 2007 and the Enrollment rate (%) of Luxembourg in 2008?
Make the answer very short. -0.88. What is the difference between the Enrollment rate (%) of Central Europe in 2007 and the Enrollment rate (%) of Latin America(all income levels) in 2010?
Your response must be concise. 1.94. What is the difference between the Enrollment rate (%) in Central Europe in 2007 and the Enrollment rate (%) in North America in 2010?
Your answer should be compact. 2.25. What is the difference between the Enrollment rate (%) in Central Europe in 2007 and the Enrollment rate (%) in Luxembourg in 2010?
Offer a terse response. 2.07. What is the difference between the Enrollment rate (%) of Latin America(all income levels) in 2007 and the Enrollment rate (%) of North America in 2010?
Ensure brevity in your answer.  0.94. What is the difference between the Enrollment rate (%) of Latin America(all income levels) in 2007 and the Enrollment rate (%) of Luxembourg in 2010?
Your response must be concise. 0.76. What is the difference between the Enrollment rate (%) of North America in 2007 and the Enrollment rate (%) of Luxembourg in 2010?
Make the answer very short. 1.78. What is the difference between the Enrollment rate (%) of Central Europe in 2008 and the Enrollment rate (%) of Latin America(all income levels) in 2010?
Give a very brief answer. 2.08. What is the difference between the Enrollment rate (%) of Central Europe in 2008 and the Enrollment rate (%) of North America in 2010?
Your answer should be very brief. 2.39. What is the difference between the Enrollment rate (%) in Central Europe in 2008 and the Enrollment rate (%) in Luxembourg in 2010?
Provide a short and direct response. 2.21. What is the difference between the Enrollment rate (%) of Latin America(all income levels) in 2008 and the Enrollment rate (%) of North America in 2010?
Keep it short and to the point. 0.13. What is the difference between the Enrollment rate (%) in Latin America(all income levels) in 2008 and the Enrollment rate (%) in Luxembourg in 2010?
Offer a very short reply. -0.05. What is the difference between the Enrollment rate (%) of North America in 2008 and the Enrollment rate (%) of Luxembourg in 2010?
Ensure brevity in your answer.  2.1. What is the average Enrollment rate (%) of Central Europe per year?
Ensure brevity in your answer.  96.15. What is the average Enrollment rate (%) in Latin America(all income levels) per year?
Provide a short and direct response. 95.29. What is the average Enrollment rate (%) in North America per year?
Your answer should be very brief. 94.56. What is the average Enrollment rate (%) of Luxembourg per year?
Ensure brevity in your answer.  96.54. In the year 2002, what is the difference between the Enrollment rate (%) in Central Europe and Enrollment rate (%) in Latin America(all income levels)?
Give a very brief answer. -0.11. In the year 2002, what is the difference between the Enrollment rate (%) of Central Europe and Enrollment rate (%) of North America?
Offer a terse response. 1.84. In the year 2002, what is the difference between the Enrollment rate (%) of Central Europe and Enrollment rate (%) of Luxembourg?
Provide a short and direct response. -0.33. In the year 2002, what is the difference between the Enrollment rate (%) of Latin America(all income levels) and Enrollment rate (%) of North America?
Provide a short and direct response. 1.96. In the year 2002, what is the difference between the Enrollment rate (%) of Latin America(all income levels) and Enrollment rate (%) of Luxembourg?
Your response must be concise. -0.21. In the year 2002, what is the difference between the Enrollment rate (%) in North America and Enrollment rate (%) in Luxembourg?
Keep it short and to the point. -2.17. In the year 2003, what is the difference between the Enrollment rate (%) in Central Europe and Enrollment rate (%) in Latin America(all income levels)?
Provide a succinct answer. 0.2. In the year 2003, what is the difference between the Enrollment rate (%) of Central Europe and Enrollment rate (%) of North America?
Offer a very short reply. 2.13. In the year 2003, what is the difference between the Enrollment rate (%) of Central Europe and Enrollment rate (%) of Luxembourg?
Your answer should be compact. 0.79. In the year 2003, what is the difference between the Enrollment rate (%) in Latin America(all income levels) and Enrollment rate (%) in North America?
Offer a terse response. 1.94. In the year 2003, what is the difference between the Enrollment rate (%) in Latin America(all income levels) and Enrollment rate (%) in Luxembourg?
Keep it short and to the point. 0.59. In the year 2003, what is the difference between the Enrollment rate (%) in North America and Enrollment rate (%) in Luxembourg?
Provide a short and direct response. -1.34. In the year 2004, what is the difference between the Enrollment rate (%) of Central Europe and Enrollment rate (%) of Latin America(all income levels)?
Provide a succinct answer. 0.01. In the year 2004, what is the difference between the Enrollment rate (%) of Central Europe and Enrollment rate (%) of North America?
Provide a succinct answer. 2.65. In the year 2004, what is the difference between the Enrollment rate (%) in Central Europe and Enrollment rate (%) in Luxembourg?
Your answer should be compact. -0.43. In the year 2004, what is the difference between the Enrollment rate (%) in Latin America(all income levels) and Enrollment rate (%) in North America?
Make the answer very short. 2.64. In the year 2004, what is the difference between the Enrollment rate (%) in Latin America(all income levels) and Enrollment rate (%) in Luxembourg?
Ensure brevity in your answer.  -0.44. In the year 2004, what is the difference between the Enrollment rate (%) of North America and Enrollment rate (%) of Luxembourg?
Provide a short and direct response. -3.08. In the year 2005, what is the difference between the Enrollment rate (%) in Central Europe and Enrollment rate (%) in Latin America(all income levels)?
Your answer should be very brief. 0.29. In the year 2005, what is the difference between the Enrollment rate (%) in Central Europe and Enrollment rate (%) in North America?
Your response must be concise. 2.02. In the year 2005, what is the difference between the Enrollment rate (%) of Central Europe and Enrollment rate (%) of Luxembourg?
Provide a short and direct response. -1.52. In the year 2005, what is the difference between the Enrollment rate (%) in Latin America(all income levels) and Enrollment rate (%) in North America?
Give a very brief answer. 1.73. In the year 2005, what is the difference between the Enrollment rate (%) of Latin America(all income levels) and Enrollment rate (%) of Luxembourg?
Ensure brevity in your answer.  -1.8. In the year 2005, what is the difference between the Enrollment rate (%) of North America and Enrollment rate (%) of Luxembourg?
Give a very brief answer. -3.53. In the year 2006, what is the difference between the Enrollment rate (%) of Central Europe and Enrollment rate (%) of Latin America(all income levels)?
Provide a succinct answer. 0.44. In the year 2006, what is the difference between the Enrollment rate (%) in Central Europe and Enrollment rate (%) in North America?
Your answer should be compact. 0.93. In the year 2006, what is the difference between the Enrollment rate (%) in Central Europe and Enrollment rate (%) in Luxembourg?
Offer a very short reply. -2.15. In the year 2006, what is the difference between the Enrollment rate (%) in Latin America(all income levels) and Enrollment rate (%) in North America?
Your answer should be compact. 0.49. In the year 2006, what is the difference between the Enrollment rate (%) in Latin America(all income levels) and Enrollment rate (%) in Luxembourg?
Give a very brief answer. -2.59. In the year 2006, what is the difference between the Enrollment rate (%) of North America and Enrollment rate (%) of Luxembourg?
Your response must be concise. -3.08. In the year 2007, what is the difference between the Enrollment rate (%) in Central Europe and Enrollment rate (%) in Latin America(all income levels)?
Offer a terse response. 1.31. In the year 2007, what is the difference between the Enrollment rate (%) of Central Europe and Enrollment rate (%) of North America?
Your answer should be compact. 0.29. In the year 2007, what is the difference between the Enrollment rate (%) in Central Europe and Enrollment rate (%) in Luxembourg?
Provide a short and direct response. -1.67. In the year 2007, what is the difference between the Enrollment rate (%) of Latin America(all income levels) and Enrollment rate (%) of North America?
Make the answer very short. -1.02. In the year 2007, what is the difference between the Enrollment rate (%) of Latin America(all income levels) and Enrollment rate (%) of Luxembourg?
Your answer should be compact. -2.98. In the year 2007, what is the difference between the Enrollment rate (%) in North America and Enrollment rate (%) in Luxembourg?
Provide a succinct answer. -1.96. In the year 2008, what is the difference between the Enrollment rate (%) in Central Europe and Enrollment rate (%) in Latin America(all income levels)?
Provide a short and direct response. 2.26. In the year 2008, what is the difference between the Enrollment rate (%) in Central Europe and Enrollment rate (%) in North America?
Your answer should be compact. 0.11. In the year 2008, what is the difference between the Enrollment rate (%) in Central Europe and Enrollment rate (%) in Luxembourg?
Provide a succinct answer. -0.45. In the year 2008, what is the difference between the Enrollment rate (%) of Latin America(all income levels) and Enrollment rate (%) of North America?
Give a very brief answer. -2.15. In the year 2008, what is the difference between the Enrollment rate (%) of Latin America(all income levels) and Enrollment rate (%) of Luxembourg?
Your response must be concise. -2.71. In the year 2008, what is the difference between the Enrollment rate (%) of North America and Enrollment rate (%) of Luxembourg?
Provide a succinct answer. -0.57. In the year 2010, what is the difference between the Enrollment rate (%) in Central Europe and Enrollment rate (%) in Latin America(all income levels)?
Your answer should be compact. 2.44. In the year 2010, what is the difference between the Enrollment rate (%) of Central Europe and Enrollment rate (%) of North America?
Your answer should be very brief. 2.75. In the year 2010, what is the difference between the Enrollment rate (%) of Central Europe and Enrollment rate (%) of Luxembourg?
Provide a succinct answer. 2.57. In the year 2010, what is the difference between the Enrollment rate (%) in Latin America(all income levels) and Enrollment rate (%) in North America?
Provide a succinct answer. 0.31. In the year 2010, what is the difference between the Enrollment rate (%) in Latin America(all income levels) and Enrollment rate (%) in Luxembourg?
Your response must be concise. 0.13. In the year 2010, what is the difference between the Enrollment rate (%) in North America and Enrollment rate (%) in Luxembourg?
Provide a short and direct response. -0.18. What is the ratio of the Enrollment rate (%) of Central Europe in 2002 to that in 2003?
Offer a terse response. 1. What is the ratio of the Enrollment rate (%) in North America in 2002 to that in 2003?
Ensure brevity in your answer.  1. What is the ratio of the Enrollment rate (%) of Luxembourg in 2002 to that in 2003?
Ensure brevity in your answer.  1.01. What is the ratio of the Enrollment rate (%) of Central Europe in 2002 to that in 2004?
Your answer should be very brief. 1.01. What is the ratio of the Enrollment rate (%) in Latin America(all income levels) in 2002 to that in 2004?
Provide a succinct answer. 1.01. What is the ratio of the Enrollment rate (%) of North America in 2002 to that in 2004?
Provide a succinct answer. 1.02. What is the ratio of the Enrollment rate (%) in Luxembourg in 2002 to that in 2004?
Offer a very short reply. 1.01. What is the ratio of the Enrollment rate (%) in Central Europe in 2002 to that in 2005?
Ensure brevity in your answer.  1.01. What is the ratio of the Enrollment rate (%) in Latin America(all income levels) in 2002 to that in 2005?
Provide a succinct answer. 1.01. What is the ratio of the Enrollment rate (%) of North America in 2002 to that in 2005?
Your answer should be very brief. 1.01. What is the ratio of the Enrollment rate (%) of Central Europe in 2002 to that in 2006?
Your answer should be very brief. 1.01. What is the ratio of the Enrollment rate (%) in Latin America(all income levels) in 2002 to that in 2006?
Provide a succinct answer. 1.02. What is the ratio of the Enrollment rate (%) of Luxembourg in 2002 to that in 2006?
Ensure brevity in your answer.  0.99. What is the ratio of the Enrollment rate (%) in Latin America(all income levels) in 2002 to that in 2007?
Provide a succinct answer. 1.02. What is the ratio of the Enrollment rate (%) of North America in 2002 to that in 2007?
Keep it short and to the point. 0.99. What is the ratio of the Enrollment rate (%) of Luxembourg in 2002 to that in 2007?
Provide a short and direct response. 0.99. What is the ratio of the Enrollment rate (%) of Central Europe in 2002 to that in 2008?
Provide a succinct answer. 1. What is the ratio of the Enrollment rate (%) of Latin America(all income levels) in 2002 to that in 2008?
Provide a succinct answer. 1.03. What is the ratio of the Enrollment rate (%) of North America in 2002 to that in 2008?
Offer a very short reply. 0.99. What is the ratio of the Enrollment rate (%) in Luxembourg in 2002 to that in 2008?
Provide a succinct answer. 1. What is the ratio of the Enrollment rate (%) in Central Europe in 2002 to that in 2010?
Offer a terse response. 1. What is the ratio of the Enrollment rate (%) of Latin America(all income levels) in 2002 to that in 2010?
Provide a succinct answer. 1.03. What is the ratio of the Enrollment rate (%) in Luxembourg in 2002 to that in 2010?
Provide a succinct answer. 1.03. What is the ratio of the Enrollment rate (%) in Central Europe in 2003 to that in 2004?
Your response must be concise. 1.01. What is the ratio of the Enrollment rate (%) of Latin America(all income levels) in 2003 to that in 2004?
Provide a short and direct response. 1. What is the ratio of the Enrollment rate (%) of North America in 2003 to that in 2004?
Keep it short and to the point. 1.01. What is the ratio of the Enrollment rate (%) of Luxembourg in 2003 to that in 2004?
Provide a succinct answer. 0.99. What is the ratio of the Enrollment rate (%) in Central Europe in 2003 to that in 2005?
Offer a terse response. 1.01. What is the ratio of the Enrollment rate (%) of Latin America(all income levels) in 2003 to that in 2005?
Provide a short and direct response. 1.01. What is the ratio of the Enrollment rate (%) of North America in 2003 to that in 2005?
Your answer should be compact. 1.01. What is the ratio of the Enrollment rate (%) of Luxembourg in 2003 to that in 2005?
Make the answer very short. 0.98. What is the ratio of the Enrollment rate (%) of Central Europe in 2003 to that in 2006?
Give a very brief answer. 1.01. What is the ratio of the Enrollment rate (%) of Latin America(all income levels) in 2003 to that in 2006?
Your answer should be compact. 1.01. What is the ratio of the Enrollment rate (%) of North America in 2003 to that in 2006?
Give a very brief answer. 1. What is the ratio of the Enrollment rate (%) of Luxembourg in 2003 to that in 2006?
Your answer should be very brief. 0.98. What is the ratio of the Enrollment rate (%) in Central Europe in 2003 to that in 2007?
Your answer should be compact. 1. What is the ratio of the Enrollment rate (%) in Latin America(all income levels) in 2003 to that in 2007?
Offer a very short reply. 1.02. What is the ratio of the Enrollment rate (%) of North America in 2003 to that in 2007?
Offer a very short reply. 0.98. What is the ratio of the Enrollment rate (%) of Luxembourg in 2003 to that in 2007?
Your answer should be compact. 0.98. What is the ratio of the Enrollment rate (%) of Latin America(all income levels) in 2003 to that in 2008?
Provide a short and direct response. 1.02. What is the ratio of the Enrollment rate (%) of North America in 2003 to that in 2008?
Your response must be concise. 0.98. What is the ratio of the Enrollment rate (%) of Luxembourg in 2003 to that in 2008?
Give a very brief answer. 0.99. What is the ratio of the Enrollment rate (%) of Latin America(all income levels) in 2003 to that in 2010?
Provide a succinct answer. 1.02. What is the ratio of the Enrollment rate (%) in North America in 2003 to that in 2010?
Provide a succinct answer. 1. What is the ratio of the Enrollment rate (%) in Luxembourg in 2003 to that in 2010?
Offer a terse response. 1.02. What is the ratio of the Enrollment rate (%) of Central Europe in 2004 to that in 2005?
Ensure brevity in your answer.  1. What is the ratio of the Enrollment rate (%) of North America in 2004 to that in 2005?
Provide a short and direct response. 0.99. What is the ratio of the Enrollment rate (%) in Central Europe in 2004 to that in 2006?
Make the answer very short. 1. What is the ratio of the Enrollment rate (%) in Latin America(all income levels) in 2004 to that in 2006?
Your answer should be very brief. 1.01. What is the ratio of the Enrollment rate (%) of North America in 2004 to that in 2006?
Your answer should be very brief. 0.98. What is the ratio of the Enrollment rate (%) in Latin America(all income levels) in 2004 to that in 2007?
Provide a short and direct response. 1.01. What is the ratio of the Enrollment rate (%) in North America in 2004 to that in 2007?
Your answer should be very brief. 0.97. What is the ratio of the Enrollment rate (%) of Latin America(all income levels) in 2004 to that in 2008?
Ensure brevity in your answer.  1.02. What is the ratio of the Enrollment rate (%) of North America in 2004 to that in 2008?
Your answer should be very brief. 0.97. What is the ratio of the Enrollment rate (%) in Luxembourg in 2004 to that in 2008?
Give a very brief answer. 1. What is the ratio of the Enrollment rate (%) in Central Europe in 2004 to that in 2010?
Your response must be concise. 0.99. What is the ratio of the Enrollment rate (%) in Latin America(all income levels) in 2004 to that in 2010?
Your answer should be compact. 1.02. What is the ratio of the Enrollment rate (%) of Luxembourg in 2004 to that in 2010?
Ensure brevity in your answer.  1.02. What is the ratio of the Enrollment rate (%) of North America in 2005 to that in 2006?
Offer a very short reply. 0.99. What is the ratio of the Enrollment rate (%) in Luxembourg in 2005 to that in 2006?
Offer a very short reply. 1. What is the ratio of the Enrollment rate (%) in Central Europe in 2005 to that in 2007?
Provide a short and direct response. 1. What is the ratio of the Enrollment rate (%) in Latin America(all income levels) in 2005 to that in 2007?
Give a very brief answer. 1.01. What is the ratio of the Enrollment rate (%) of North America in 2005 to that in 2007?
Offer a terse response. 0.98. What is the ratio of the Enrollment rate (%) in Luxembourg in 2005 to that in 2007?
Your response must be concise. 1. What is the ratio of the Enrollment rate (%) of Latin America(all income levels) in 2005 to that in 2008?
Your answer should be compact. 1.02. What is the ratio of the Enrollment rate (%) of North America in 2005 to that in 2008?
Your answer should be compact. 0.98. What is the ratio of the Enrollment rate (%) in Luxembourg in 2005 to that in 2008?
Ensure brevity in your answer.  1.01. What is the ratio of the Enrollment rate (%) of Central Europe in 2005 to that in 2010?
Provide a succinct answer. 0.99. What is the ratio of the Enrollment rate (%) in Latin America(all income levels) in 2005 to that in 2010?
Your answer should be very brief. 1.01. What is the ratio of the Enrollment rate (%) of Luxembourg in 2005 to that in 2010?
Your response must be concise. 1.04. What is the ratio of the Enrollment rate (%) in North America in 2006 to that in 2007?
Provide a succinct answer. 0.99. What is the ratio of the Enrollment rate (%) of Luxembourg in 2006 to that in 2007?
Your answer should be very brief. 1. What is the ratio of the Enrollment rate (%) in Latin America(all income levels) in 2006 to that in 2008?
Keep it short and to the point. 1.01. What is the ratio of the Enrollment rate (%) of North America in 2006 to that in 2008?
Make the answer very short. 0.98. What is the ratio of the Enrollment rate (%) of Luxembourg in 2006 to that in 2008?
Make the answer very short. 1.01. What is the ratio of the Enrollment rate (%) of Central Europe in 2006 to that in 2010?
Offer a very short reply. 0.99. What is the ratio of the Enrollment rate (%) of Latin America(all income levels) in 2006 to that in 2010?
Your answer should be compact. 1.01. What is the ratio of the Enrollment rate (%) of North America in 2006 to that in 2010?
Give a very brief answer. 1.01. What is the ratio of the Enrollment rate (%) of Luxembourg in 2006 to that in 2010?
Give a very brief answer. 1.04. What is the ratio of the Enrollment rate (%) of Central Europe in 2007 to that in 2008?
Provide a short and direct response. 1. What is the ratio of the Enrollment rate (%) of Latin America(all income levels) in 2007 to that in 2008?
Provide a short and direct response. 1.01. What is the ratio of the Enrollment rate (%) in Luxembourg in 2007 to that in 2008?
Offer a terse response. 1.01. What is the ratio of the Enrollment rate (%) in Central Europe in 2007 to that in 2010?
Your answer should be very brief. 0.99. What is the ratio of the Enrollment rate (%) of Latin America(all income levels) in 2007 to that in 2010?
Your response must be concise. 1.01. What is the ratio of the Enrollment rate (%) in North America in 2007 to that in 2010?
Make the answer very short. 1.02. What is the ratio of the Enrollment rate (%) of Luxembourg in 2007 to that in 2010?
Offer a terse response. 1.04. What is the ratio of the Enrollment rate (%) of Central Europe in 2008 to that in 2010?
Your answer should be compact. 1. What is the ratio of the Enrollment rate (%) of Latin America(all income levels) in 2008 to that in 2010?
Your response must be concise. 1. What is the ratio of the Enrollment rate (%) of North America in 2008 to that in 2010?
Your response must be concise. 1.02. What is the ratio of the Enrollment rate (%) of Luxembourg in 2008 to that in 2010?
Your response must be concise. 1.03. What is the difference between the highest and the second highest Enrollment rate (%) in Central Europe?
Offer a terse response. 0.06. What is the difference between the highest and the second highest Enrollment rate (%) in Latin America(all income levels)?
Ensure brevity in your answer.  0.39. What is the difference between the highest and the second highest Enrollment rate (%) of North America?
Keep it short and to the point. 0.32. What is the difference between the highest and the second highest Enrollment rate (%) of Luxembourg?
Make the answer very short. 0.05. What is the difference between the highest and the lowest Enrollment rate (%) in Central Europe?
Keep it short and to the point. 1.04. What is the difference between the highest and the lowest Enrollment rate (%) in Latin America(all income levels)?
Make the answer very short. 2.67. What is the difference between the highest and the lowest Enrollment rate (%) in North America?
Give a very brief answer. 2.93. What is the difference between the highest and the lowest Enrollment rate (%) of Luxembourg?
Offer a terse response. 3.74. 